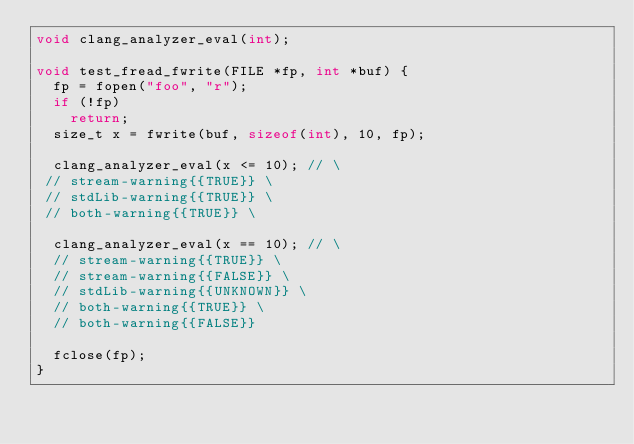Convert code to text. <code><loc_0><loc_0><loc_500><loc_500><_C_>void clang_analyzer_eval(int);

void test_fread_fwrite(FILE *fp, int *buf) {
  fp = fopen("foo", "r");
  if (!fp)
    return;
  size_t x = fwrite(buf, sizeof(int), 10, fp);

  clang_analyzer_eval(x <= 10); // \
 // stream-warning{{TRUE}} \
 // stdLib-warning{{TRUE}} \
 // both-warning{{TRUE}} \

  clang_analyzer_eval(x == 10); // \
  // stream-warning{{TRUE}} \
  // stream-warning{{FALSE}} \
  // stdLib-warning{{UNKNOWN}} \
  // both-warning{{TRUE}} \
  // both-warning{{FALSE}}

  fclose(fp);
}
</code> 